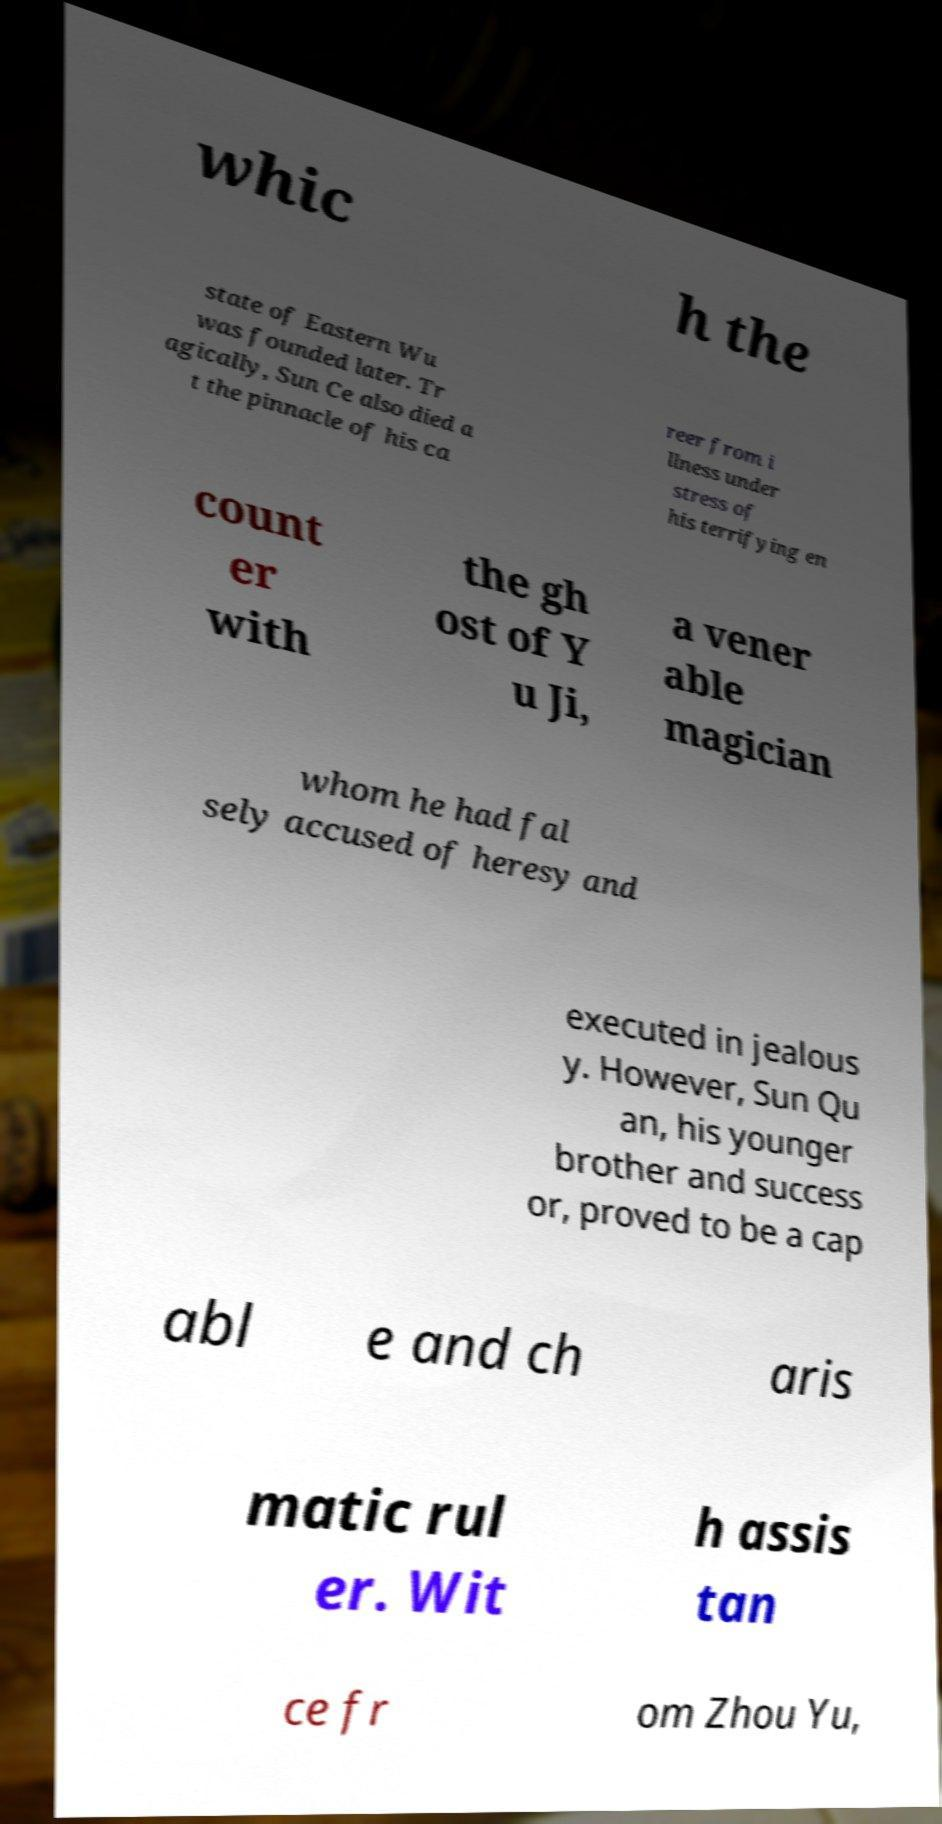I need the written content from this picture converted into text. Can you do that? whic h the state of Eastern Wu was founded later. Tr agically, Sun Ce also died a t the pinnacle of his ca reer from i llness under stress of his terrifying en count er with the gh ost of Y u Ji, a vener able magician whom he had fal sely accused of heresy and executed in jealous y. However, Sun Qu an, his younger brother and success or, proved to be a cap abl e and ch aris matic rul er. Wit h assis tan ce fr om Zhou Yu, 